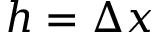Convert formula to latex. <formula><loc_0><loc_0><loc_500><loc_500>h = \Delta x</formula> 